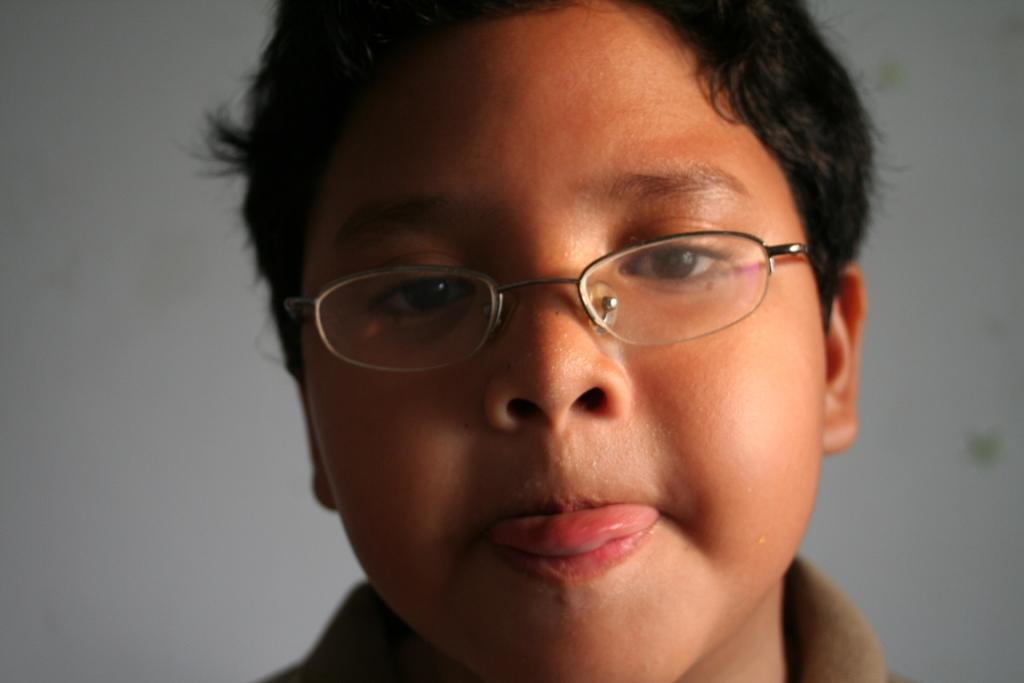Who is the main subject in the image? There is a boy in the image. What is the boy wearing in the image? The boy is wearing spectacles in the image. What can be seen in the background of the image? There is a wall in the background of the image. What type of polish is the boy applying to the rail in the image? There is no rail or polish present in the image; it only features a boy wearing spectacles and a wall in the background. 